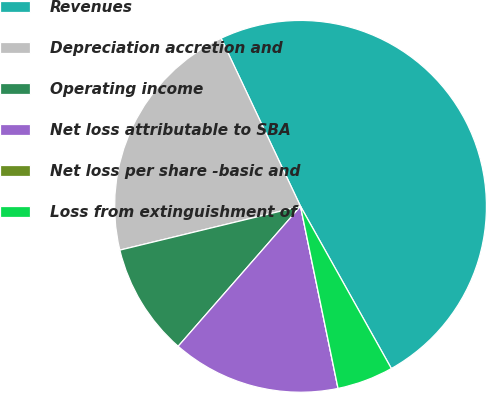Convert chart to OTSL. <chart><loc_0><loc_0><loc_500><loc_500><pie_chart><fcel>Revenues<fcel>Depreciation accretion and<fcel>Operating income<fcel>Net loss attributable to SBA<fcel>Net loss per share -basic and<fcel>Loss from extinguishment of<nl><fcel>48.9%<fcel>21.76%<fcel>9.78%<fcel>14.67%<fcel>0.0%<fcel>4.89%<nl></chart> 